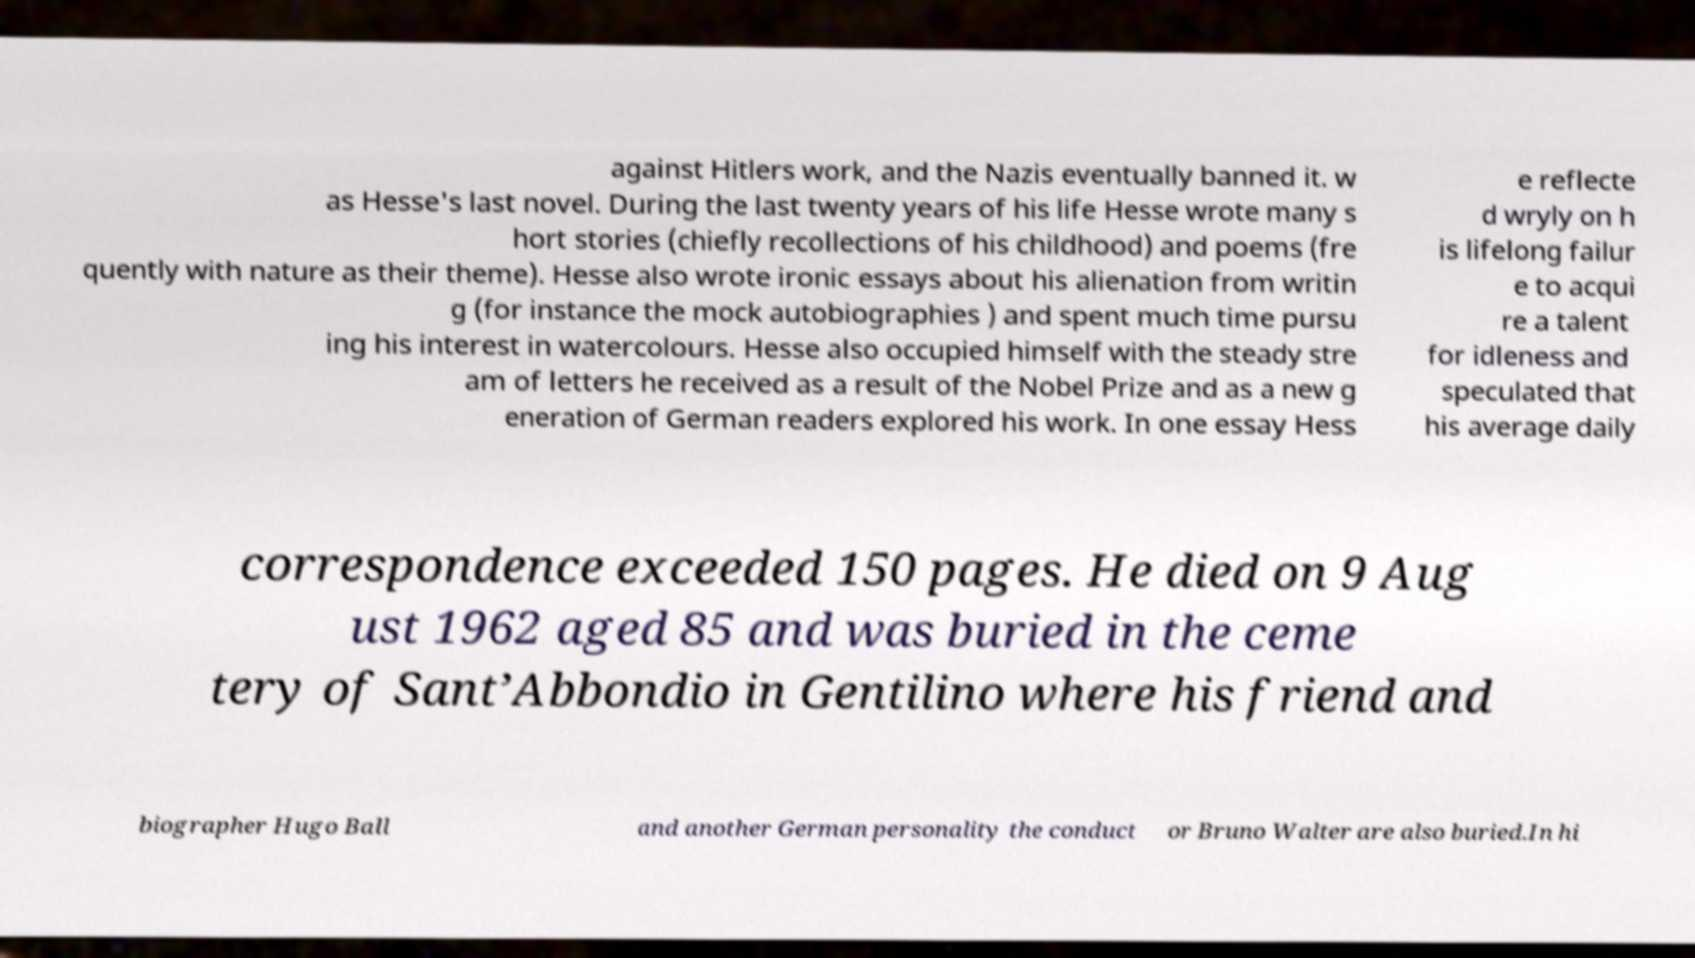Can you read and provide the text displayed in the image?This photo seems to have some interesting text. Can you extract and type it out for me? against Hitlers work, and the Nazis eventually banned it. w as Hesse's last novel. During the last twenty years of his life Hesse wrote many s hort stories (chiefly recollections of his childhood) and poems (fre quently with nature as their theme). Hesse also wrote ironic essays about his alienation from writin g (for instance the mock autobiographies ) and spent much time pursu ing his interest in watercolours. Hesse also occupied himself with the steady stre am of letters he received as a result of the Nobel Prize and as a new g eneration of German readers explored his work. In one essay Hess e reflecte d wryly on h is lifelong failur e to acqui re a talent for idleness and speculated that his average daily correspondence exceeded 150 pages. He died on 9 Aug ust 1962 aged 85 and was buried in the ceme tery of Sant’Abbondio in Gentilino where his friend and biographer Hugo Ball and another German personality the conduct or Bruno Walter are also buried.In hi 